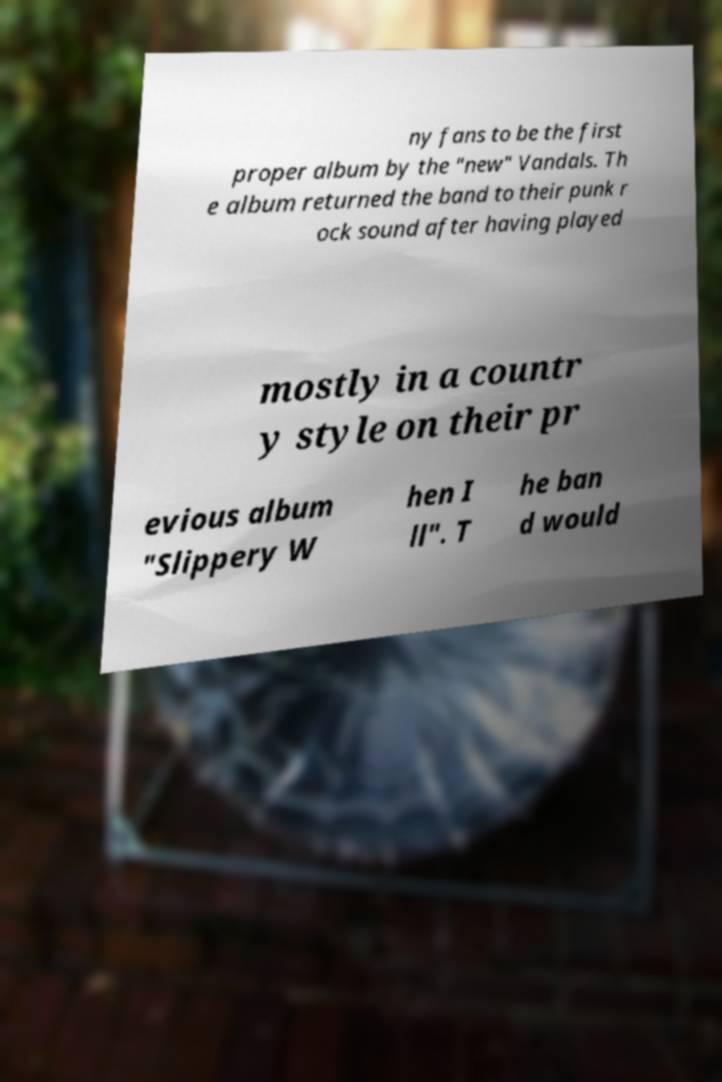Could you extract and type out the text from this image? ny fans to be the first proper album by the "new" Vandals. Th e album returned the band to their punk r ock sound after having played mostly in a countr y style on their pr evious album "Slippery W hen I ll". T he ban d would 